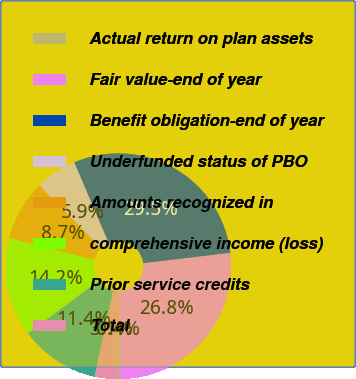Convert chart to OTSL. <chart><loc_0><loc_0><loc_500><loc_500><pie_chart><fcel>Actual return on plan assets<fcel>Fair value-end of year<fcel>Benefit obligation-end of year<fcel>Underfunded status of PBO<fcel>Amounts recognized in<fcel>comprehensive income (loss)<fcel>Prior service credits<fcel>Total<nl><fcel>0.38%<fcel>26.75%<fcel>29.52%<fcel>5.91%<fcel>8.67%<fcel>14.19%<fcel>11.43%<fcel>3.14%<nl></chart> 